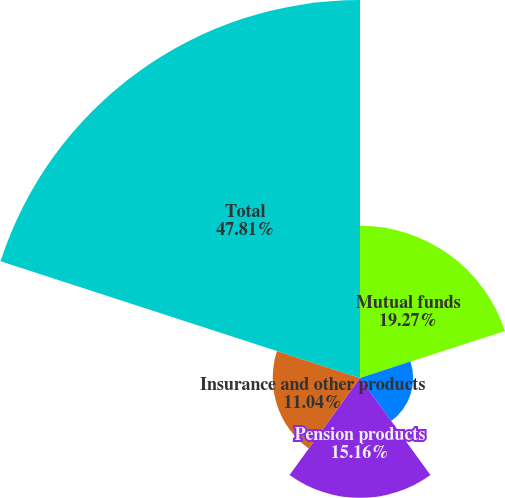<chart> <loc_0><loc_0><loc_500><loc_500><pie_chart><fcel>Mutual funds<fcel>Collective funds<fcel>Pension products<fcel>Insurance and other products<fcel>Total<nl><fcel>19.27%<fcel>6.72%<fcel>15.16%<fcel>11.04%<fcel>47.82%<nl></chart> 